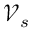<formula> <loc_0><loc_0><loc_500><loc_500>\mathcal { V } _ { s }</formula> 